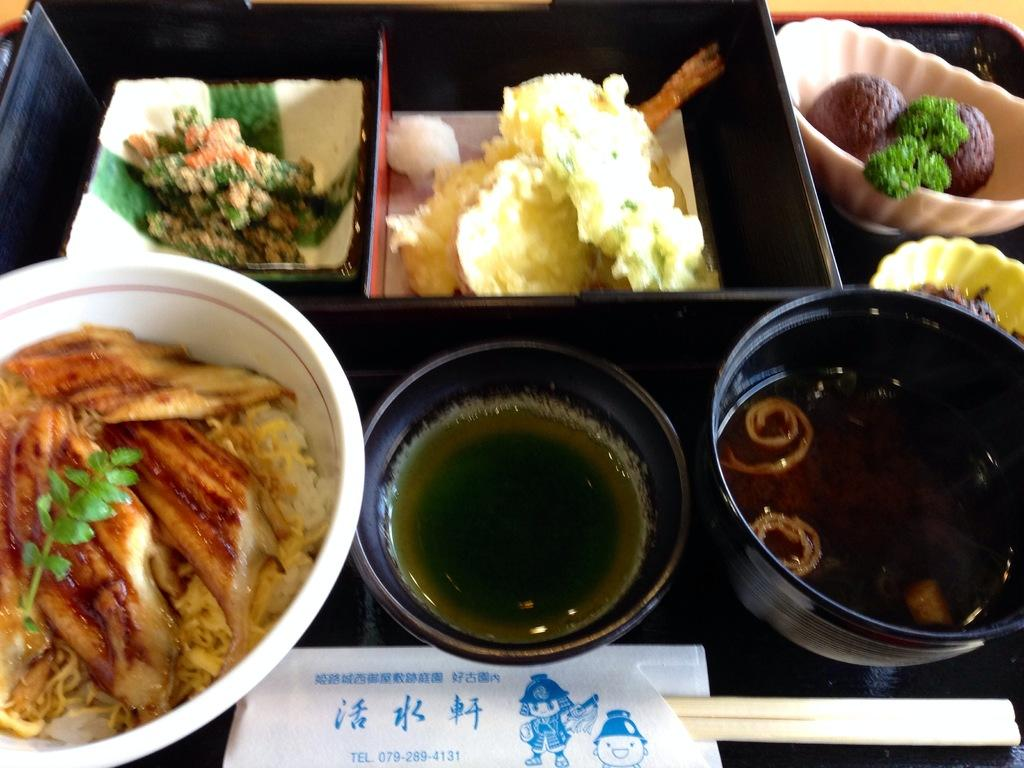What is the main subject of the image? The main subject of the image is a table with food items arranged on it. Can you describe the food items on the table? Unfortunately, the provided facts do not specify the types of food items on the table. What might be the purpose of the food items on the table? The purpose of the food items on the table could be for a meal, a gathering, or a celebration. What type of test can be seen being conducted on the table in the image? There is no test or testing equipment visible in the image; it only shows food items arranged on a table. 